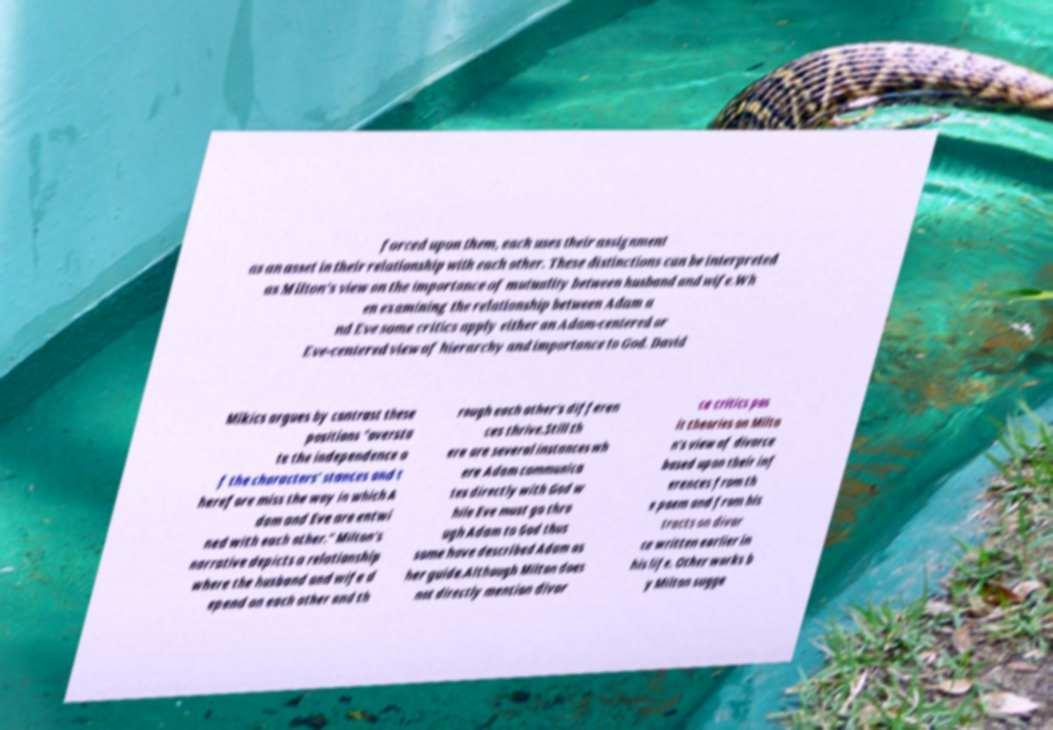Could you extract and type out the text from this image? forced upon them, each uses their assignment as an asset in their relationship with each other. These distinctions can be interpreted as Milton's view on the importance of mutuality between husband and wife.Wh en examining the relationship between Adam a nd Eve some critics apply either an Adam-centered or Eve-centered view of hierarchy and importance to God. David Mikics argues by contrast these positions "oversta te the independence o f the characters' stances and t herefore miss the way in which A dam and Eve are entwi ned with each other." Milton's narrative depicts a relationship where the husband and wife d epend on each other and th rough each other's differen ces thrive.Still th ere are several instances wh ere Adam communica tes directly with God w hile Eve must go thro ugh Adam to God thus some have described Adam as her guide.Although Milton does not directly mention divor ce critics pos it theories on Milto n's view of divorce based upon their inf erences from th e poem and from his tracts on divor ce written earlier in his life. Other works b y Milton sugge 